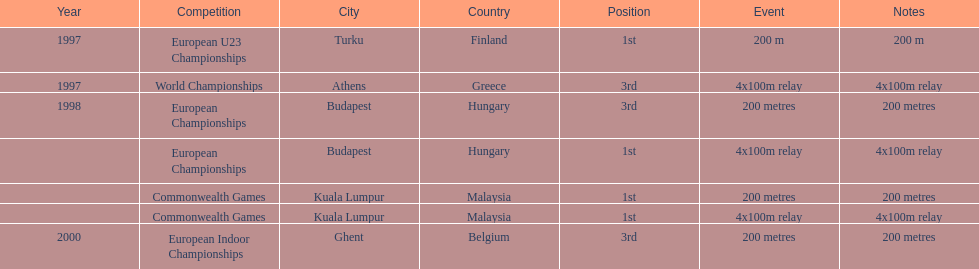How many total years did golding compete? 3. 